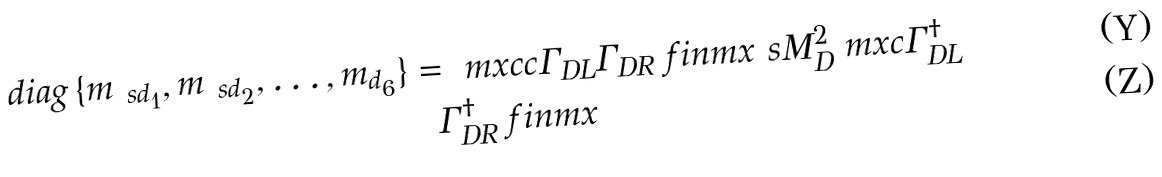<formula> <loc_0><loc_0><loc_500><loc_500>d i a g \, \{ m _ { \ s d _ { 1 } } , m _ { \ s d _ { 2 } } , \dots , m _ { d _ { 6 } } \} = \ m x { c c } \Gamma _ { D L } & \Gamma _ { D R } \ f i n m x { \ s M _ { D } ^ { 2 } } \ m x { c } \Gamma _ { D L } ^ { \dagger } \\ \Gamma _ { D R } ^ { \dagger } \ f i n m x</formula> 